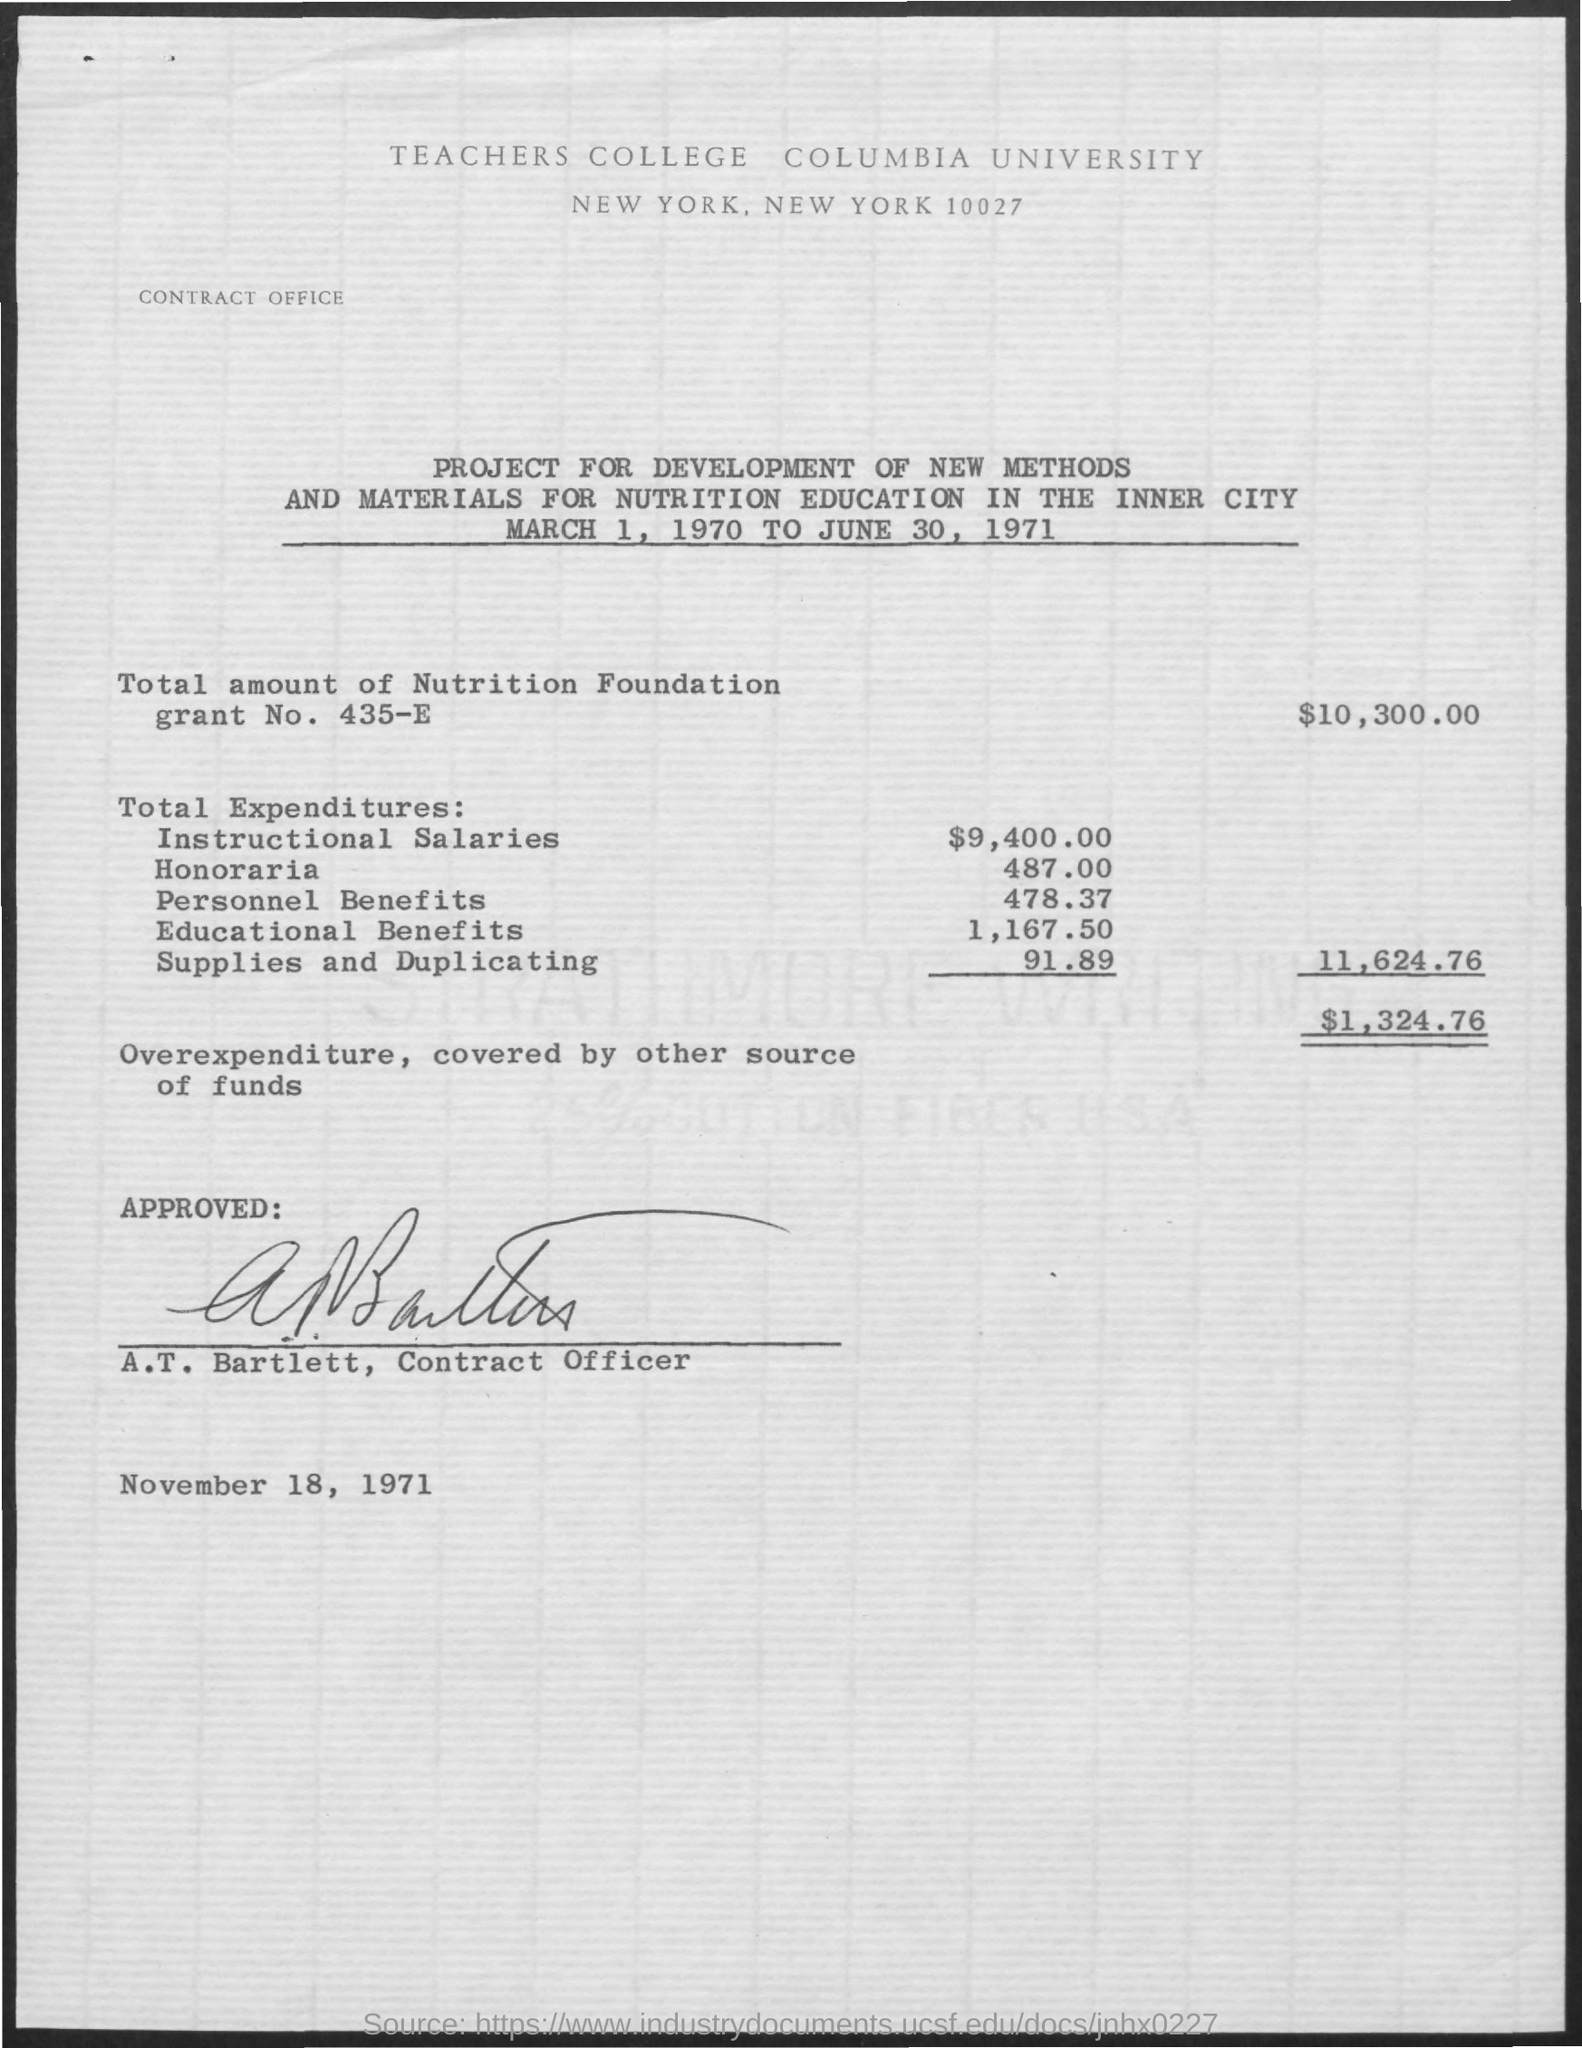What is the total amount of nutrition foundation grant no . 435-e
Your answer should be very brief. $10,300.00. In which city columbia university located
Your answer should be compact. New york. What is the name of the contract officer ?
Provide a short and direct response. A.T. Bartlett. What is the date of approved ?
Your response must be concise. November 18, 1971. What is the total expenditure of instructional salaries ?
Ensure brevity in your answer.  $9,400.00. What is the date mentioned for the project development of new methods and materials
Your response must be concise. March 1, 1970 to june 30 , 1971. What is the total expenditure of personal benefits
Your answer should be compact. $478.37. What is the total expenditure of supplies and duplicating
Provide a succinct answer. $ 91.89. 